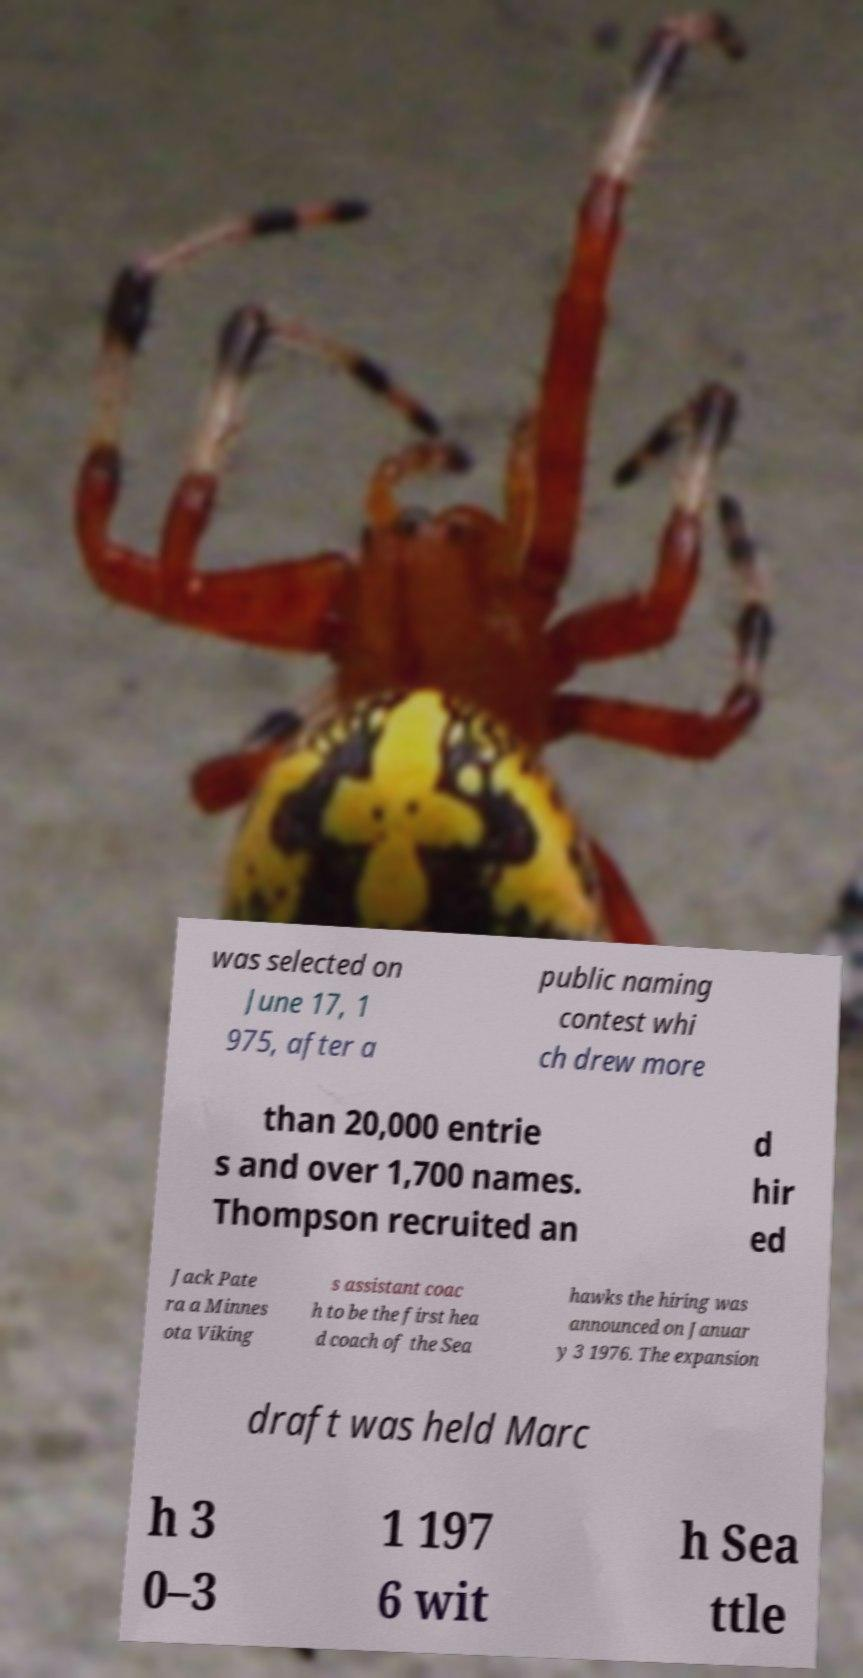Can you accurately transcribe the text from the provided image for me? was selected on June 17, 1 975, after a public naming contest whi ch drew more than 20,000 entrie s and over 1,700 names. Thompson recruited an d hir ed Jack Pate ra a Minnes ota Viking s assistant coac h to be the first hea d coach of the Sea hawks the hiring was announced on Januar y 3 1976. The expansion draft was held Marc h 3 0–3 1 197 6 wit h Sea ttle 